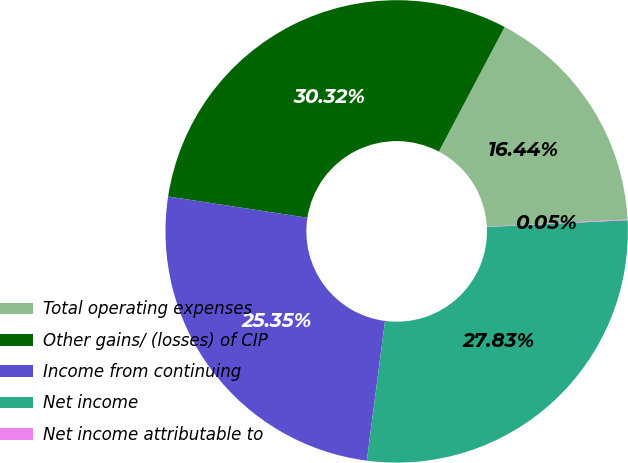Convert chart. <chart><loc_0><loc_0><loc_500><loc_500><pie_chart><fcel>Total operating expenses<fcel>Other gains/ (losses) of CIP<fcel>Income from continuing<fcel>Net income<fcel>Net income attributable to<nl><fcel>16.44%<fcel>30.32%<fcel>25.35%<fcel>27.83%<fcel>0.05%<nl></chart> 